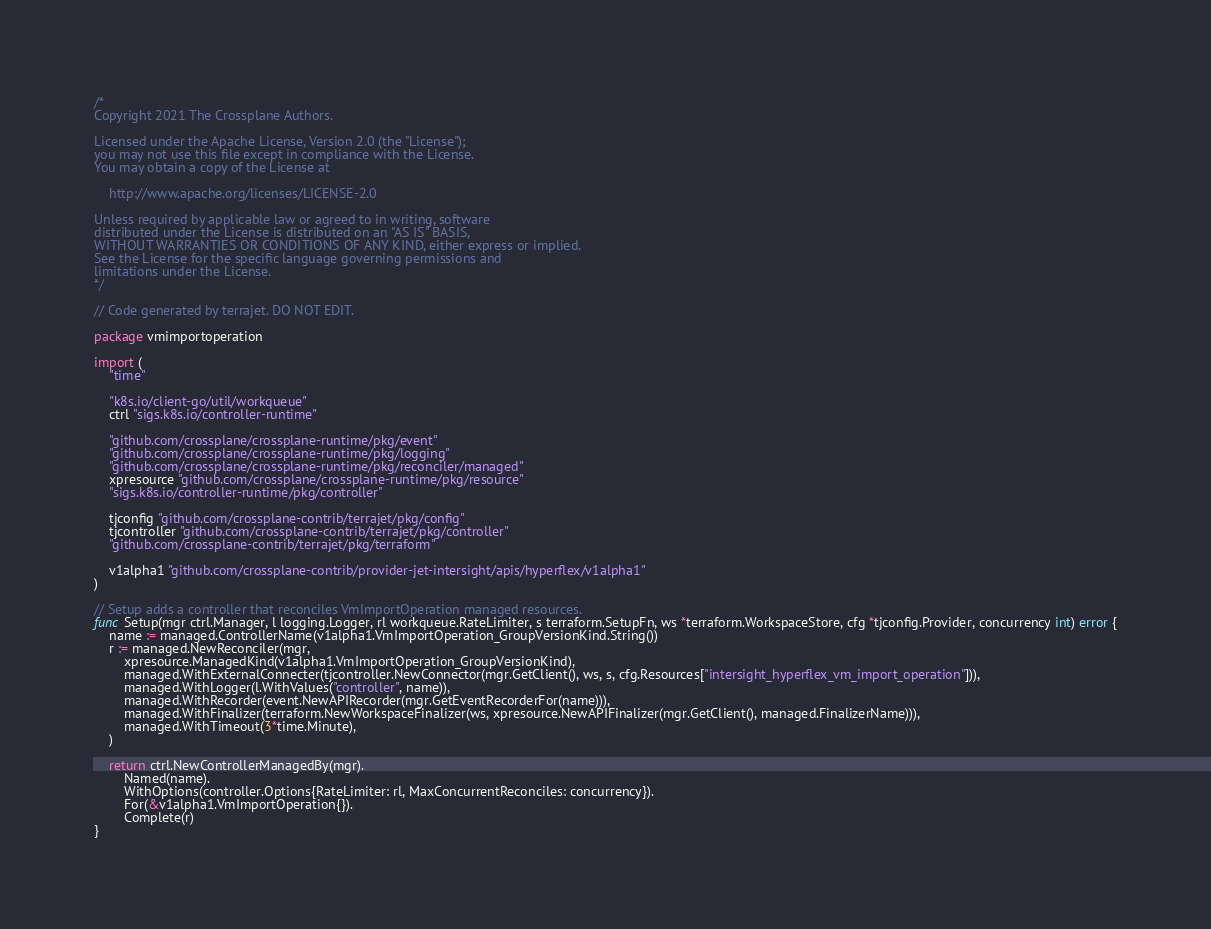Convert code to text. <code><loc_0><loc_0><loc_500><loc_500><_Go_>/*
Copyright 2021 The Crossplane Authors.

Licensed under the Apache License, Version 2.0 (the "License");
you may not use this file except in compliance with the License.
You may obtain a copy of the License at

    http://www.apache.org/licenses/LICENSE-2.0

Unless required by applicable law or agreed to in writing, software
distributed under the License is distributed on an "AS IS" BASIS,
WITHOUT WARRANTIES OR CONDITIONS OF ANY KIND, either express or implied.
See the License for the specific language governing permissions and
limitations under the License.
*/

// Code generated by terrajet. DO NOT EDIT.

package vmimportoperation

import (
	"time"

	"k8s.io/client-go/util/workqueue"
	ctrl "sigs.k8s.io/controller-runtime"

	"github.com/crossplane/crossplane-runtime/pkg/event"
	"github.com/crossplane/crossplane-runtime/pkg/logging"
	"github.com/crossplane/crossplane-runtime/pkg/reconciler/managed"
	xpresource "github.com/crossplane/crossplane-runtime/pkg/resource"
	"sigs.k8s.io/controller-runtime/pkg/controller"

	tjconfig "github.com/crossplane-contrib/terrajet/pkg/config"
	tjcontroller "github.com/crossplane-contrib/terrajet/pkg/controller"
	"github.com/crossplane-contrib/terrajet/pkg/terraform"

	v1alpha1 "github.com/crossplane-contrib/provider-jet-intersight/apis/hyperflex/v1alpha1"
)

// Setup adds a controller that reconciles VmImportOperation managed resources.
func Setup(mgr ctrl.Manager, l logging.Logger, rl workqueue.RateLimiter, s terraform.SetupFn, ws *terraform.WorkspaceStore, cfg *tjconfig.Provider, concurrency int) error {
	name := managed.ControllerName(v1alpha1.VmImportOperation_GroupVersionKind.String())
	r := managed.NewReconciler(mgr,
		xpresource.ManagedKind(v1alpha1.VmImportOperation_GroupVersionKind),
		managed.WithExternalConnecter(tjcontroller.NewConnector(mgr.GetClient(), ws, s, cfg.Resources["intersight_hyperflex_vm_import_operation"])),
		managed.WithLogger(l.WithValues("controller", name)),
		managed.WithRecorder(event.NewAPIRecorder(mgr.GetEventRecorderFor(name))),
		managed.WithFinalizer(terraform.NewWorkspaceFinalizer(ws, xpresource.NewAPIFinalizer(mgr.GetClient(), managed.FinalizerName))),
		managed.WithTimeout(3*time.Minute),
	)

	return ctrl.NewControllerManagedBy(mgr).
		Named(name).
		WithOptions(controller.Options{RateLimiter: rl, MaxConcurrentReconciles: concurrency}).
		For(&v1alpha1.VmImportOperation{}).
		Complete(r)
}
</code> 